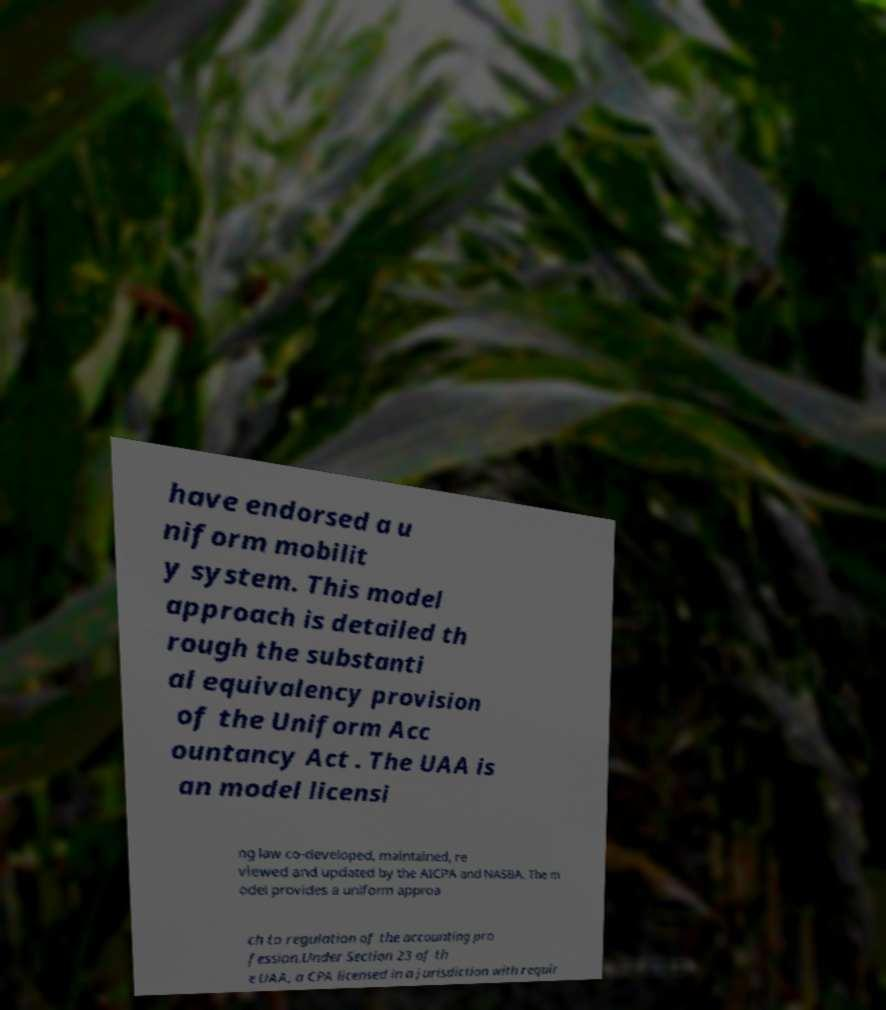There's text embedded in this image that I need extracted. Can you transcribe it verbatim? have endorsed a u niform mobilit y system. This model approach is detailed th rough the substanti al equivalency provision of the Uniform Acc ountancy Act . The UAA is an model licensi ng law co-developed, maintained, re viewed and updated by the AICPA and NASBA. The m odel provides a uniform approa ch to regulation of the accounting pro fession.Under Section 23 of th e UAA, a CPA licensed in a jurisdiction with requir 